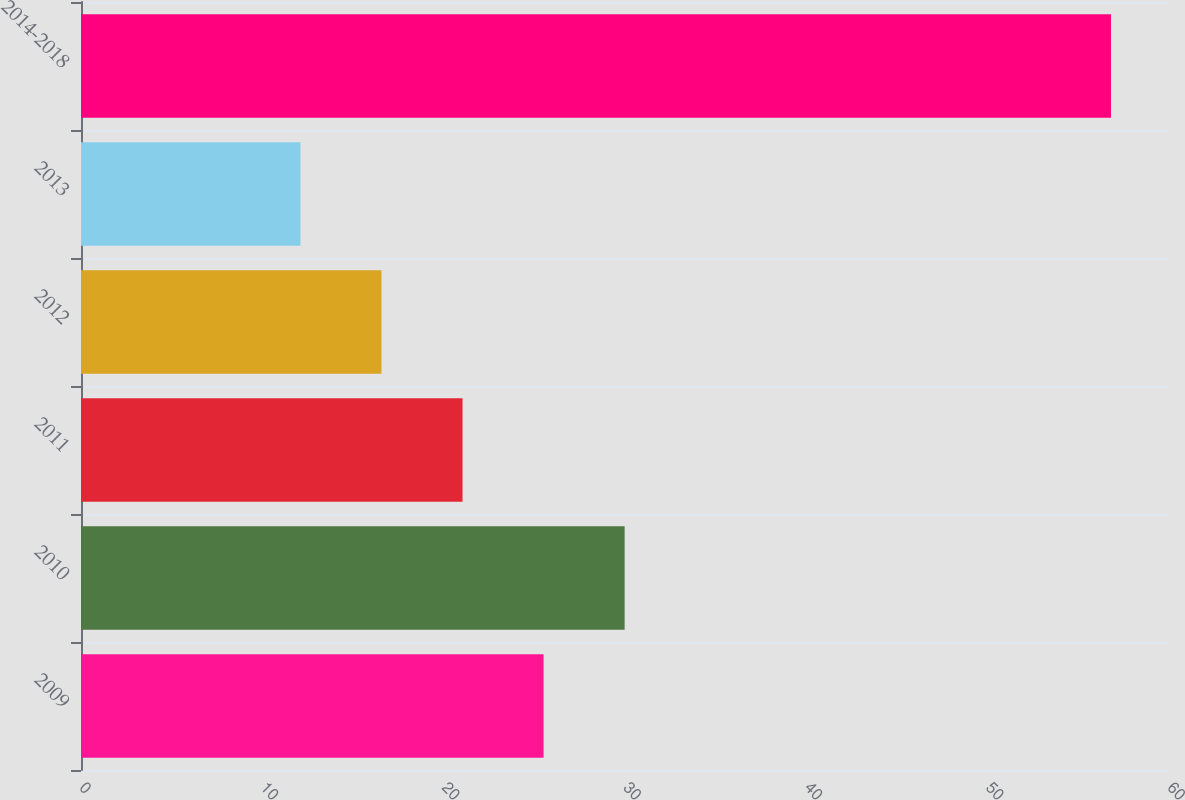Convert chart. <chart><loc_0><loc_0><loc_500><loc_500><bar_chart><fcel>2009<fcel>2010<fcel>2011<fcel>2012<fcel>2013<fcel>2014-2018<nl><fcel>25.51<fcel>29.98<fcel>21.04<fcel>16.57<fcel>12.1<fcel>56.8<nl></chart> 